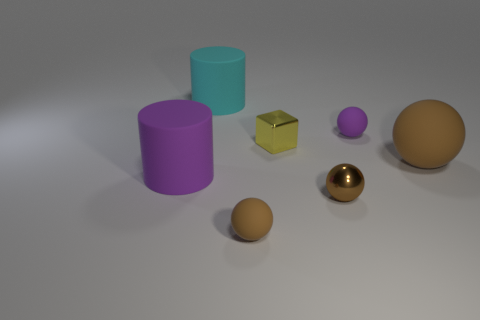Is the color of the tiny rubber sphere that is behind the purple rubber cylinder the same as the cylinder in front of the big brown matte ball?
Provide a short and direct response. Yes. There is a big ball that is right of the small yellow metal thing; is there a object that is in front of it?
Offer a very short reply. Yes. Is the number of large purple cylinders in front of the purple rubber cylinder less than the number of brown matte balls right of the small brown metal ball?
Provide a succinct answer. Yes. Is the material of the purple thing that is to the left of the tiny brown matte ball the same as the small brown sphere right of the yellow shiny cube?
Ensure brevity in your answer.  No. How many tiny objects are either green shiny blocks or matte objects?
Your answer should be very brief. 2. There is another brown thing that is made of the same material as the big brown object; what shape is it?
Your answer should be very brief. Sphere. Is the number of yellow metallic cubes that are on the left side of the yellow shiny cube less than the number of large blue rubber spheres?
Provide a succinct answer. No. Is the shape of the small yellow shiny object the same as the tiny brown matte thing?
Make the answer very short. No. What number of rubber objects are big purple cylinders or large brown objects?
Ensure brevity in your answer.  2. Are there any shiny blocks of the same size as the purple rubber sphere?
Provide a succinct answer. Yes. 